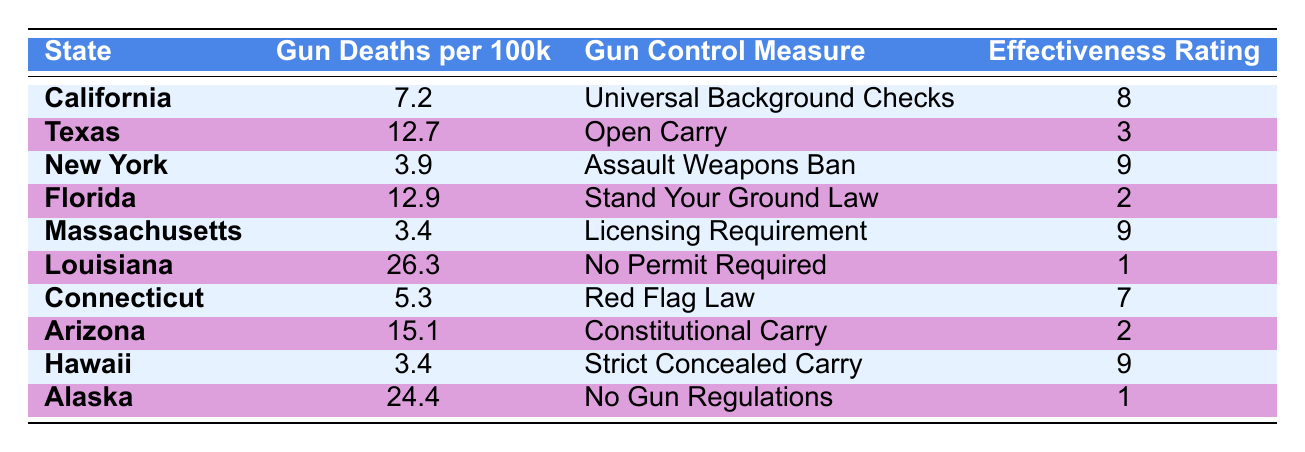What state has the highest gun deaths per 100k? From the table, Louisiana has the highest gun deaths per 100k, displaying a figure of 26.3.
Answer: Louisiana Which gun control measure has the highest effectiveness rating? The Assault Weapons Ban in New York, Licensing Requirement in Massachusetts, and Strict Concealed Carry in Hawaii all share the highest effectiveness rating of 9.
Answer: Assault Weapons Ban, Licensing Requirement, Strict Concealed Carry How many states have a gun deaths per 100k lower than 5? The table lists Massachusetts and Hawaii, with gun deaths per 100k at 3.4, and New York at 3.9, giving a total of 3 states.
Answer: 3 Is the effectiveness rating for the No Permit Required measure greater than 2? The effectiveness rating for No Permit Required in Louisiana is 1, which is indeed not greater than 2. Thus, the answer is no.
Answer: No Which state with a gun control measure rated below 5 has the highest gun deaths per 100k? The table shows that Florida has the Stand Your Ground Law rated 2, with gun deaths per 100k at 12.9, which is the highest among those with ratings below 5.
Answer: Florida What is the average gun deaths per 100k for states with effectiveness ratings of 9? The states with effectiveness ratings of 9 (New York, Massachusetts, and Hawaii) have gun deaths of 3.9, 3.4, and 3.4 respectively. Adding these gives 10.7, and dividing by 3 provides an average of approximately 3.57.
Answer: 3.57 Are there any states with open carry laws that have lower gun deaths per 100k than California? Texas, which has open carry laws, shows 12.7 gun deaths per 100k, which is higher than California's 7.2, making the answer no.
Answer: No What pattern do you see between gun control measures and their effectiveness ratings? Observing the table, strict measures like the Assault Weapons Ban and Licensing Requirement correspond to higher effectiveness ratings, while more lenient measures like No Permit Required and Open Carry relate to lower ratings.
Answer: Stricter measures correlate with higher ratings 